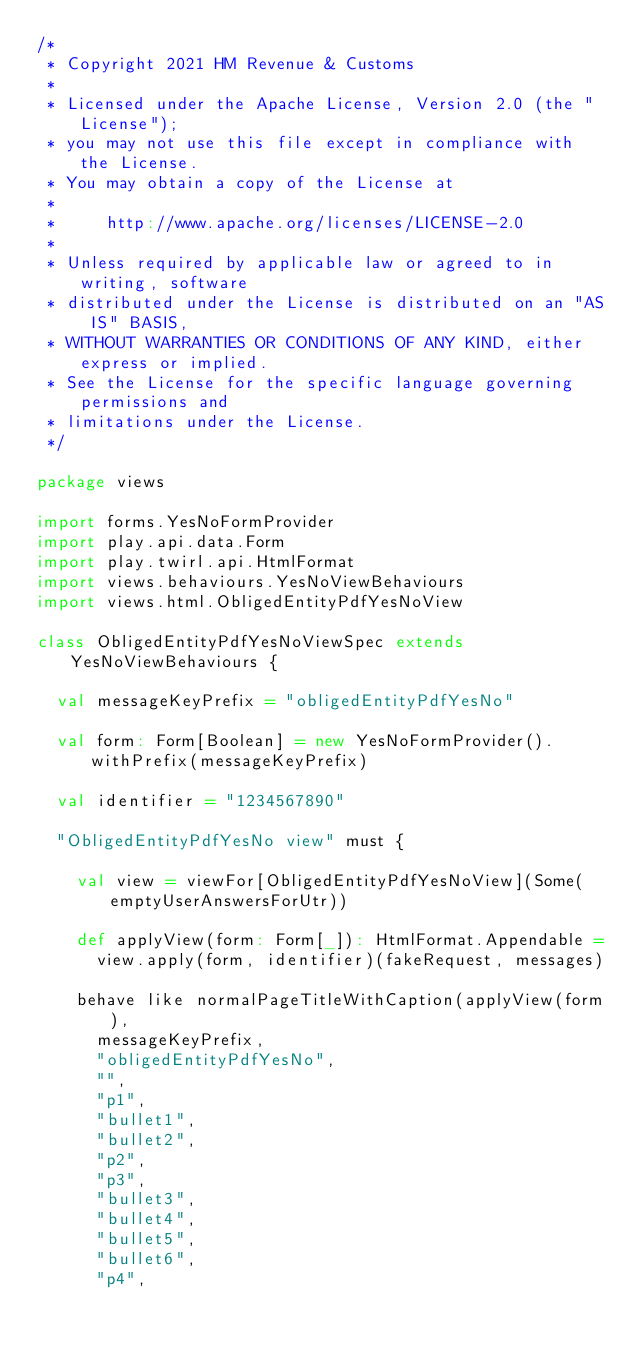Convert code to text. <code><loc_0><loc_0><loc_500><loc_500><_Scala_>/*
 * Copyright 2021 HM Revenue & Customs
 *
 * Licensed under the Apache License, Version 2.0 (the "License");
 * you may not use this file except in compliance with the License.
 * You may obtain a copy of the License at
 *
 *     http://www.apache.org/licenses/LICENSE-2.0
 *
 * Unless required by applicable law or agreed to in writing, software
 * distributed under the License is distributed on an "AS IS" BASIS,
 * WITHOUT WARRANTIES OR CONDITIONS OF ANY KIND, either express or implied.
 * See the License for the specific language governing permissions and
 * limitations under the License.
 */

package views

import forms.YesNoFormProvider
import play.api.data.Form
import play.twirl.api.HtmlFormat
import views.behaviours.YesNoViewBehaviours
import views.html.ObligedEntityPdfYesNoView

class ObligedEntityPdfYesNoViewSpec extends YesNoViewBehaviours {

  val messageKeyPrefix = "obligedEntityPdfYesNo"

  val form: Form[Boolean] = new YesNoFormProvider().withPrefix(messageKeyPrefix)

  val identifier = "1234567890"
  
  "ObligedEntityPdfYesNo view" must {

    val view = viewFor[ObligedEntityPdfYesNoView](Some(emptyUserAnswersForUtr))

    def applyView(form: Form[_]): HtmlFormat.Appendable =
      view.apply(form, identifier)(fakeRequest, messages)

    behave like normalPageTitleWithCaption(applyView(form),
      messageKeyPrefix,
      "obligedEntityPdfYesNo",
      "",
      "p1",
      "bullet1",
      "bullet2",
      "p2",
      "p3",
      "bullet3",
      "bullet4",
      "bullet5",
      "bullet6",
      "p4",</code> 